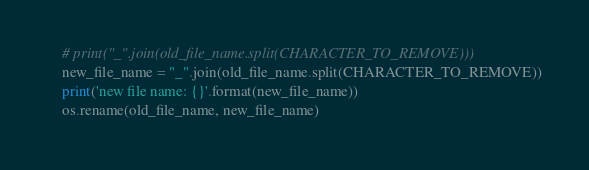<code> <loc_0><loc_0><loc_500><loc_500><_Python_>    # print("_".join(old_file_name.split(CHARACTER_TO_REMOVE)))
    new_file_name = "_".join(old_file_name.split(CHARACTER_TO_REMOVE))
    print('new file name: {}'.format(new_file_name))
    os.rename(old_file_name, new_file_name)</code> 